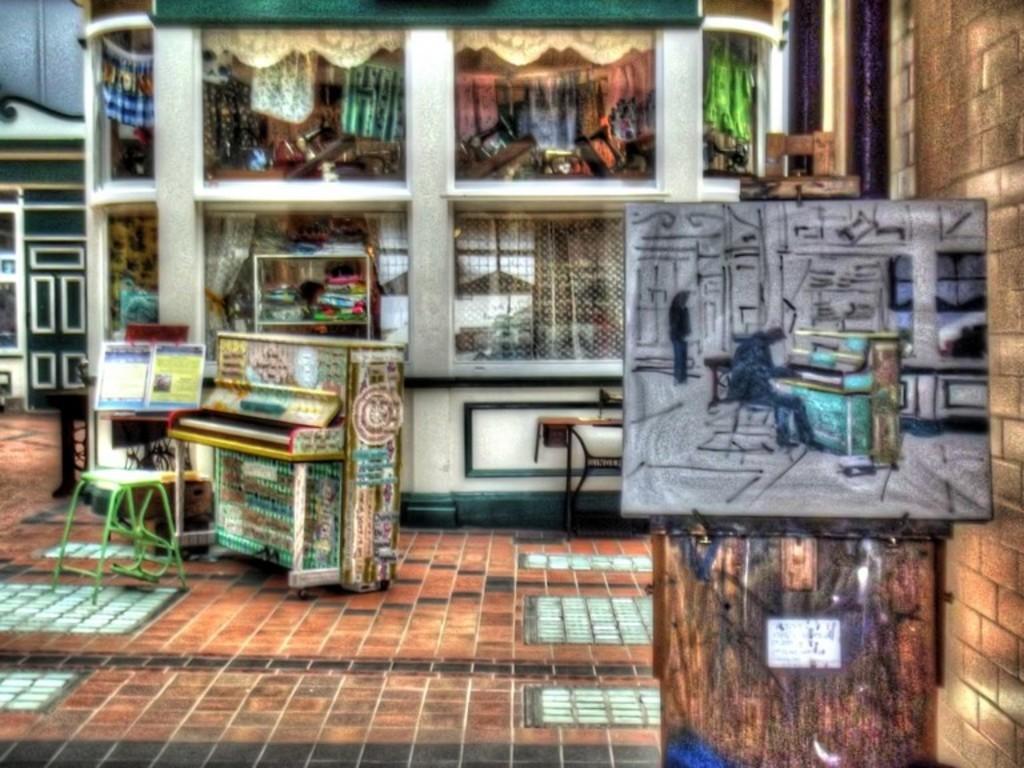Could you give a brief overview of what you see in this image? This image is an animated image. At the bottom of the image there is a floor. In the middle of the image there is a table. On the right side of the image there is a wall and there is a board. In the background there is a building with walls and windows. On the left side of the image there is another building. 